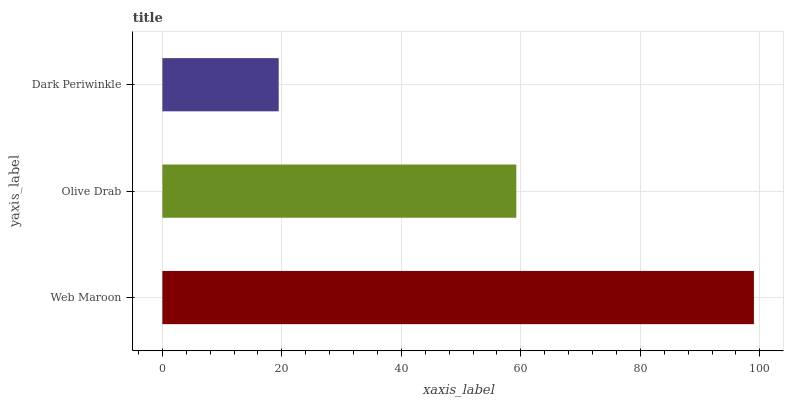Is Dark Periwinkle the minimum?
Answer yes or no. Yes. Is Web Maroon the maximum?
Answer yes or no. Yes. Is Olive Drab the minimum?
Answer yes or no. No. Is Olive Drab the maximum?
Answer yes or no. No. Is Web Maroon greater than Olive Drab?
Answer yes or no. Yes. Is Olive Drab less than Web Maroon?
Answer yes or no. Yes. Is Olive Drab greater than Web Maroon?
Answer yes or no. No. Is Web Maroon less than Olive Drab?
Answer yes or no. No. Is Olive Drab the high median?
Answer yes or no. Yes. Is Olive Drab the low median?
Answer yes or no. Yes. Is Dark Periwinkle the high median?
Answer yes or no. No. Is Dark Periwinkle the low median?
Answer yes or no. No. 